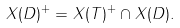<formula> <loc_0><loc_0><loc_500><loc_500>X ( D ) ^ { + } = X ( T ) ^ { + } \cap X ( D ) .</formula> 